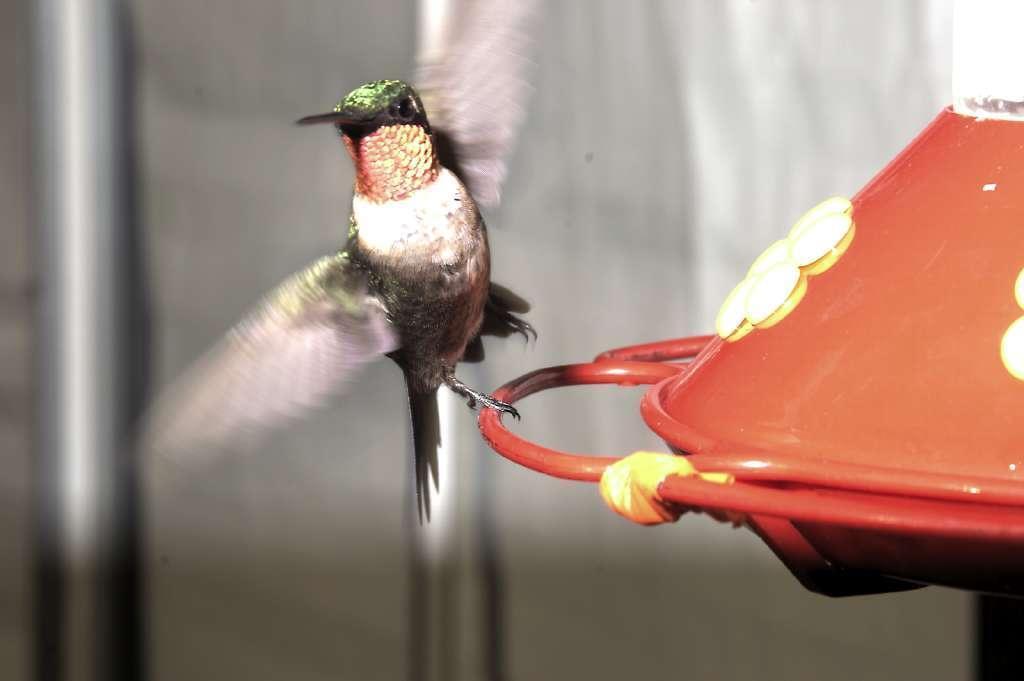Could you give a brief overview of what you see in this image? In this picture we can see an object, bird and in the background we can see poles and it is blurry. 